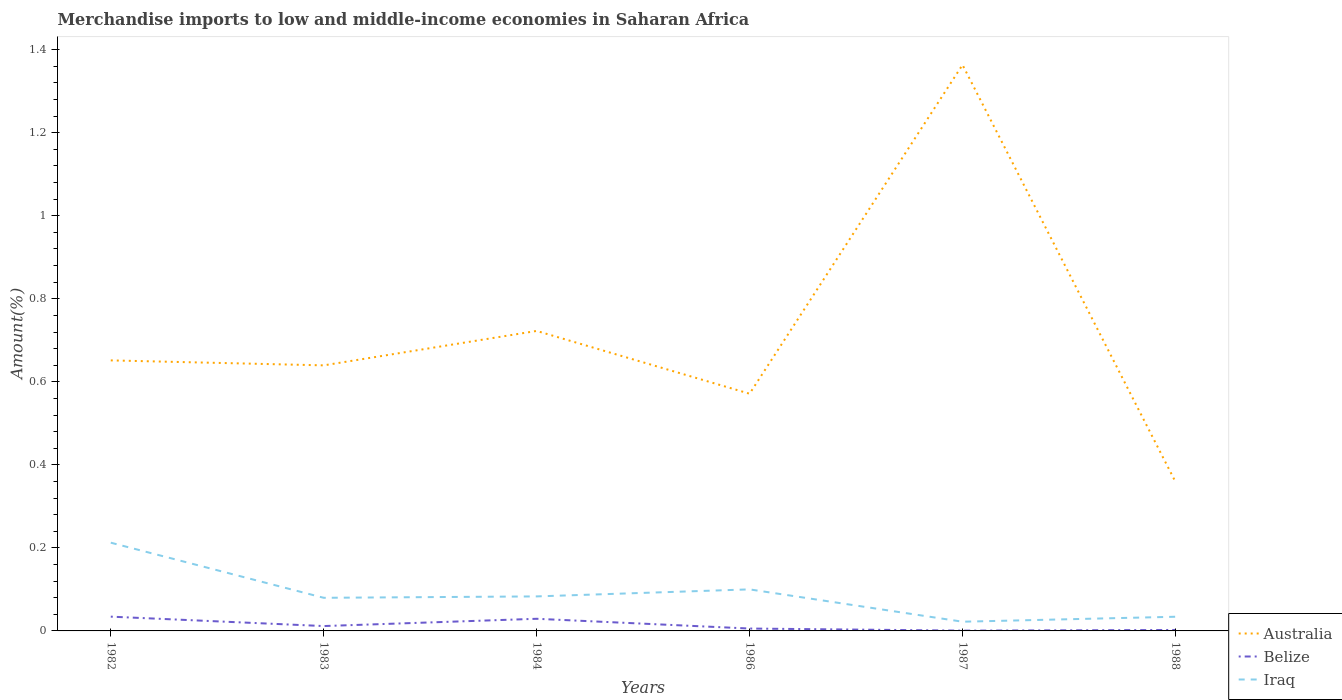Across all years, what is the maximum percentage of amount earned from merchandise imports in Iraq?
Keep it short and to the point. 0.02. What is the total percentage of amount earned from merchandise imports in Australia in the graph?
Your answer should be very brief. 0.28. What is the difference between the highest and the second highest percentage of amount earned from merchandise imports in Australia?
Your response must be concise. 1. Is the percentage of amount earned from merchandise imports in Belize strictly greater than the percentage of amount earned from merchandise imports in Australia over the years?
Your answer should be very brief. Yes. How many lines are there?
Offer a very short reply. 3. Are the values on the major ticks of Y-axis written in scientific E-notation?
Make the answer very short. No. Does the graph contain grids?
Make the answer very short. No. Where does the legend appear in the graph?
Give a very brief answer. Bottom right. How are the legend labels stacked?
Give a very brief answer. Vertical. What is the title of the graph?
Offer a very short reply. Merchandise imports to low and middle-income economies in Saharan Africa. Does "Caribbean small states" appear as one of the legend labels in the graph?
Your response must be concise. No. What is the label or title of the X-axis?
Your response must be concise. Years. What is the label or title of the Y-axis?
Keep it short and to the point. Amount(%). What is the Amount(%) in Australia in 1982?
Your answer should be compact. 0.65. What is the Amount(%) of Belize in 1982?
Your answer should be very brief. 0.03. What is the Amount(%) of Iraq in 1982?
Provide a succinct answer. 0.21. What is the Amount(%) in Australia in 1983?
Offer a terse response. 0.64. What is the Amount(%) of Belize in 1983?
Offer a terse response. 0.01. What is the Amount(%) of Iraq in 1983?
Your answer should be very brief. 0.08. What is the Amount(%) in Australia in 1984?
Offer a very short reply. 0.72. What is the Amount(%) of Belize in 1984?
Your answer should be very brief. 0.03. What is the Amount(%) of Iraq in 1984?
Keep it short and to the point. 0.08. What is the Amount(%) of Australia in 1986?
Provide a short and direct response. 0.57. What is the Amount(%) of Belize in 1986?
Offer a very short reply. 0.01. What is the Amount(%) of Iraq in 1986?
Make the answer very short. 0.1. What is the Amount(%) of Australia in 1987?
Make the answer very short. 1.36. What is the Amount(%) of Belize in 1987?
Offer a very short reply. 0. What is the Amount(%) in Iraq in 1987?
Provide a short and direct response. 0.02. What is the Amount(%) of Australia in 1988?
Offer a terse response. 0.36. What is the Amount(%) of Belize in 1988?
Offer a very short reply. 0. What is the Amount(%) of Iraq in 1988?
Your answer should be compact. 0.03. Across all years, what is the maximum Amount(%) of Australia?
Provide a short and direct response. 1.36. Across all years, what is the maximum Amount(%) of Belize?
Ensure brevity in your answer.  0.03. Across all years, what is the maximum Amount(%) of Iraq?
Provide a succinct answer. 0.21. Across all years, what is the minimum Amount(%) of Australia?
Provide a succinct answer. 0.36. Across all years, what is the minimum Amount(%) in Belize?
Your answer should be compact. 0. Across all years, what is the minimum Amount(%) in Iraq?
Make the answer very short. 0.02. What is the total Amount(%) in Australia in the graph?
Your answer should be compact. 4.31. What is the total Amount(%) of Belize in the graph?
Provide a short and direct response. 0.08. What is the total Amount(%) in Iraq in the graph?
Your answer should be compact. 0.53. What is the difference between the Amount(%) in Australia in 1982 and that in 1983?
Make the answer very short. 0.01. What is the difference between the Amount(%) of Belize in 1982 and that in 1983?
Your response must be concise. 0.02. What is the difference between the Amount(%) of Iraq in 1982 and that in 1983?
Ensure brevity in your answer.  0.13. What is the difference between the Amount(%) of Australia in 1982 and that in 1984?
Keep it short and to the point. -0.07. What is the difference between the Amount(%) in Belize in 1982 and that in 1984?
Your answer should be very brief. 0.01. What is the difference between the Amount(%) of Iraq in 1982 and that in 1984?
Provide a short and direct response. 0.13. What is the difference between the Amount(%) in Australia in 1982 and that in 1986?
Offer a very short reply. 0.08. What is the difference between the Amount(%) in Belize in 1982 and that in 1986?
Offer a terse response. 0.03. What is the difference between the Amount(%) of Iraq in 1982 and that in 1986?
Your response must be concise. 0.11. What is the difference between the Amount(%) in Australia in 1982 and that in 1987?
Your answer should be very brief. -0.71. What is the difference between the Amount(%) in Belize in 1982 and that in 1987?
Your response must be concise. 0.03. What is the difference between the Amount(%) of Iraq in 1982 and that in 1987?
Make the answer very short. 0.19. What is the difference between the Amount(%) of Australia in 1982 and that in 1988?
Provide a succinct answer. 0.29. What is the difference between the Amount(%) of Belize in 1982 and that in 1988?
Provide a succinct answer. 0.03. What is the difference between the Amount(%) in Iraq in 1982 and that in 1988?
Give a very brief answer. 0.18. What is the difference between the Amount(%) in Australia in 1983 and that in 1984?
Give a very brief answer. -0.08. What is the difference between the Amount(%) of Belize in 1983 and that in 1984?
Provide a short and direct response. -0.02. What is the difference between the Amount(%) in Iraq in 1983 and that in 1984?
Your answer should be compact. -0. What is the difference between the Amount(%) of Australia in 1983 and that in 1986?
Ensure brevity in your answer.  0.07. What is the difference between the Amount(%) in Belize in 1983 and that in 1986?
Your response must be concise. 0.01. What is the difference between the Amount(%) of Iraq in 1983 and that in 1986?
Ensure brevity in your answer.  -0.02. What is the difference between the Amount(%) in Australia in 1983 and that in 1987?
Your response must be concise. -0.72. What is the difference between the Amount(%) of Belize in 1983 and that in 1987?
Ensure brevity in your answer.  0.01. What is the difference between the Amount(%) of Iraq in 1983 and that in 1987?
Ensure brevity in your answer.  0.06. What is the difference between the Amount(%) in Australia in 1983 and that in 1988?
Make the answer very short. 0.28. What is the difference between the Amount(%) of Belize in 1983 and that in 1988?
Offer a very short reply. 0.01. What is the difference between the Amount(%) of Iraq in 1983 and that in 1988?
Ensure brevity in your answer.  0.05. What is the difference between the Amount(%) of Australia in 1984 and that in 1986?
Offer a very short reply. 0.15. What is the difference between the Amount(%) in Belize in 1984 and that in 1986?
Give a very brief answer. 0.02. What is the difference between the Amount(%) of Iraq in 1984 and that in 1986?
Provide a short and direct response. -0.02. What is the difference between the Amount(%) in Australia in 1984 and that in 1987?
Give a very brief answer. -0.64. What is the difference between the Amount(%) in Belize in 1984 and that in 1987?
Keep it short and to the point. 0.03. What is the difference between the Amount(%) of Iraq in 1984 and that in 1987?
Give a very brief answer. 0.06. What is the difference between the Amount(%) of Australia in 1984 and that in 1988?
Ensure brevity in your answer.  0.36. What is the difference between the Amount(%) in Belize in 1984 and that in 1988?
Keep it short and to the point. 0.03. What is the difference between the Amount(%) in Iraq in 1984 and that in 1988?
Give a very brief answer. 0.05. What is the difference between the Amount(%) of Australia in 1986 and that in 1987?
Make the answer very short. -0.79. What is the difference between the Amount(%) of Belize in 1986 and that in 1987?
Your answer should be compact. 0.01. What is the difference between the Amount(%) in Iraq in 1986 and that in 1987?
Your answer should be very brief. 0.08. What is the difference between the Amount(%) of Australia in 1986 and that in 1988?
Provide a succinct answer. 0.21. What is the difference between the Amount(%) of Belize in 1986 and that in 1988?
Ensure brevity in your answer.  0. What is the difference between the Amount(%) in Iraq in 1986 and that in 1988?
Provide a short and direct response. 0.07. What is the difference between the Amount(%) of Belize in 1987 and that in 1988?
Offer a very short reply. -0. What is the difference between the Amount(%) of Iraq in 1987 and that in 1988?
Your response must be concise. -0.01. What is the difference between the Amount(%) in Australia in 1982 and the Amount(%) in Belize in 1983?
Give a very brief answer. 0.64. What is the difference between the Amount(%) in Australia in 1982 and the Amount(%) in Iraq in 1983?
Give a very brief answer. 0.57. What is the difference between the Amount(%) in Belize in 1982 and the Amount(%) in Iraq in 1983?
Your response must be concise. -0.05. What is the difference between the Amount(%) in Australia in 1982 and the Amount(%) in Belize in 1984?
Offer a very short reply. 0.62. What is the difference between the Amount(%) in Australia in 1982 and the Amount(%) in Iraq in 1984?
Your answer should be compact. 0.57. What is the difference between the Amount(%) in Belize in 1982 and the Amount(%) in Iraq in 1984?
Offer a terse response. -0.05. What is the difference between the Amount(%) in Australia in 1982 and the Amount(%) in Belize in 1986?
Provide a succinct answer. 0.65. What is the difference between the Amount(%) of Australia in 1982 and the Amount(%) of Iraq in 1986?
Give a very brief answer. 0.55. What is the difference between the Amount(%) in Belize in 1982 and the Amount(%) in Iraq in 1986?
Provide a succinct answer. -0.07. What is the difference between the Amount(%) of Australia in 1982 and the Amount(%) of Belize in 1987?
Give a very brief answer. 0.65. What is the difference between the Amount(%) in Australia in 1982 and the Amount(%) in Iraq in 1987?
Your response must be concise. 0.63. What is the difference between the Amount(%) of Belize in 1982 and the Amount(%) of Iraq in 1987?
Keep it short and to the point. 0.01. What is the difference between the Amount(%) in Australia in 1982 and the Amount(%) in Belize in 1988?
Give a very brief answer. 0.65. What is the difference between the Amount(%) of Australia in 1982 and the Amount(%) of Iraq in 1988?
Your answer should be very brief. 0.62. What is the difference between the Amount(%) in Belize in 1982 and the Amount(%) in Iraq in 1988?
Your response must be concise. 0. What is the difference between the Amount(%) of Australia in 1983 and the Amount(%) of Belize in 1984?
Your response must be concise. 0.61. What is the difference between the Amount(%) of Australia in 1983 and the Amount(%) of Iraq in 1984?
Give a very brief answer. 0.56. What is the difference between the Amount(%) of Belize in 1983 and the Amount(%) of Iraq in 1984?
Offer a very short reply. -0.07. What is the difference between the Amount(%) in Australia in 1983 and the Amount(%) in Belize in 1986?
Offer a very short reply. 0.63. What is the difference between the Amount(%) of Australia in 1983 and the Amount(%) of Iraq in 1986?
Your answer should be very brief. 0.54. What is the difference between the Amount(%) in Belize in 1983 and the Amount(%) in Iraq in 1986?
Provide a succinct answer. -0.09. What is the difference between the Amount(%) in Australia in 1983 and the Amount(%) in Belize in 1987?
Keep it short and to the point. 0.64. What is the difference between the Amount(%) of Australia in 1983 and the Amount(%) of Iraq in 1987?
Your response must be concise. 0.62. What is the difference between the Amount(%) of Belize in 1983 and the Amount(%) of Iraq in 1987?
Provide a succinct answer. -0.01. What is the difference between the Amount(%) of Australia in 1983 and the Amount(%) of Belize in 1988?
Keep it short and to the point. 0.64. What is the difference between the Amount(%) of Australia in 1983 and the Amount(%) of Iraq in 1988?
Offer a terse response. 0.61. What is the difference between the Amount(%) in Belize in 1983 and the Amount(%) in Iraq in 1988?
Your answer should be compact. -0.02. What is the difference between the Amount(%) of Australia in 1984 and the Amount(%) of Belize in 1986?
Make the answer very short. 0.72. What is the difference between the Amount(%) in Australia in 1984 and the Amount(%) in Iraq in 1986?
Give a very brief answer. 0.62. What is the difference between the Amount(%) in Belize in 1984 and the Amount(%) in Iraq in 1986?
Your answer should be compact. -0.07. What is the difference between the Amount(%) in Australia in 1984 and the Amount(%) in Belize in 1987?
Make the answer very short. 0.72. What is the difference between the Amount(%) in Australia in 1984 and the Amount(%) in Iraq in 1987?
Your answer should be compact. 0.7. What is the difference between the Amount(%) of Belize in 1984 and the Amount(%) of Iraq in 1987?
Your response must be concise. 0.01. What is the difference between the Amount(%) in Australia in 1984 and the Amount(%) in Belize in 1988?
Offer a very short reply. 0.72. What is the difference between the Amount(%) of Australia in 1984 and the Amount(%) of Iraq in 1988?
Your answer should be very brief. 0.69. What is the difference between the Amount(%) in Belize in 1984 and the Amount(%) in Iraq in 1988?
Make the answer very short. -0. What is the difference between the Amount(%) of Australia in 1986 and the Amount(%) of Belize in 1987?
Ensure brevity in your answer.  0.57. What is the difference between the Amount(%) of Australia in 1986 and the Amount(%) of Iraq in 1987?
Provide a succinct answer. 0.55. What is the difference between the Amount(%) in Belize in 1986 and the Amount(%) in Iraq in 1987?
Your answer should be very brief. -0.02. What is the difference between the Amount(%) in Australia in 1986 and the Amount(%) in Belize in 1988?
Your answer should be compact. 0.57. What is the difference between the Amount(%) in Australia in 1986 and the Amount(%) in Iraq in 1988?
Make the answer very short. 0.54. What is the difference between the Amount(%) of Belize in 1986 and the Amount(%) of Iraq in 1988?
Your response must be concise. -0.03. What is the difference between the Amount(%) in Australia in 1987 and the Amount(%) in Belize in 1988?
Provide a succinct answer. 1.36. What is the difference between the Amount(%) of Australia in 1987 and the Amount(%) of Iraq in 1988?
Make the answer very short. 1.33. What is the difference between the Amount(%) of Belize in 1987 and the Amount(%) of Iraq in 1988?
Offer a very short reply. -0.03. What is the average Amount(%) of Australia per year?
Your answer should be compact. 0.72. What is the average Amount(%) in Belize per year?
Your answer should be very brief. 0.01. What is the average Amount(%) in Iraq per year?
Your answer should be compact. 0.09. In the year 1982, what is the difference between the Amount(%) of Australia and Amount(%) of Belize?
Your answer should be very brief. 0.62. In the year 1982, what is the difference between the Amount(%) in Australia and Amount(%) in Iraq?
Your answer should be compact. 0.44. In the year 1982, what is the difference between the Amount(%) of Belize and Amount(%) of Iraq?
Offer a terse response. -0.18. In the year 1983, what is the difference between the Amount(%) in Australia and Amount(%) in Belize?
Provide a succinct answer. 0.63. In the year 1983, what is the difference between the Amount(%) in Australia and Amount(%) in Iraq?
Ensure brevity in your answer.  0.56. In the year 1983, what is the difference between the Amount(%) of Belize and Amount(%) of Iraq?
Your response must be concise. -0.07. In the year 1984, what is the difference between the Amount(%) in Australia and Amount(%) in Belize?
Ensure brevity in your answer.  0.69. In the year 1984, what is the difference between the Amount(%) in Australia and Amount(%) in Iraq?
Your answer should be very brief. 0.64. In the year 1984, what is the difference between the Amount(%) in Belize and Amount(%) in Iraq?
Keep it short and to the point. -0.05. In the year 1986, what is the difference between the Amount(%) of Australia and Amount(%) of Belize?
Give a very brief answer. 0.57. In the year 1986, what is the difference between the Amount(%) in Australia and Amount(%) in Iraq?
Provide a succinct answer. 0.47. In the year 1986, what is the difference between the Amount(%) in Belize and Amount(%) in Iraq?
Provide a short and direct response. -0.09. In the year 1987, what is the difference between the Amount(%) of Australia and Amount(%) of Belize?
Your response must be concise. 1.36. In the year 1987, what is the difference between the Amount(%) in Australia and Amount(%) in Iraq?
Your response must be concise. 1.34. In the year 1987, what is the difference between the Amount(%) in Belize and Amount(%) in Iraq?
Keep it short and to the point. -0.02. In the year 1988, what is the difference between the Amount(%) of Australia and Amount(%) of Belize?
Keep it short and to the point. 0.36. In the year 1988, what is the difference between the Amount(%) in Australia and Amount(%) in Iraq?
Your answer should be compact. 0.33. In the year 1988, what is the difference between the Amount(%) of Belize and Amount(%) of Iraq?
Provide a succinct answer. -0.03. What is the ratio of the Amount(%) of Australia in 1982 to that in 1983?
Provide a short and direct response. 1.02. What is the ratio of the Amount(%) in Belize in 1982 to that in 1983?
Your answer should be very brief. 2.93. What is the ratio of the Amount(%) of Iraq in 1982 to that in 1983?
Your response must be concise. 2.66. What is the ratio of the Amount(%) of Australia in 1982 to that in 1984?
Keep it short and to the point. 0.9. What is the ratio of the Amount(%) in Belize in 1982 to that in 1984?
Keep it short and to the point. 1.18. What is the ratio of the Amount(%) of Iraq in 1982 to that in 1984?
Ensure brevity in your answer.  2.56. What is the ratio of the Amount(%) of Australia in 1982 to that in 1986?
Give a very brief answer. 1.14. What is the ratio of the Amount(%) in Belize in 1982 to that in 1986?
Give a very brief answer. 5.99. What is the ratio of the Amount(%) in Iraq in 1982 to that in 1986?
Ensure brevity in your answer.  2.12. What is the ratio of the Amount(%) of Australia in 1982 to that in 1987?
Make the answer very short. 0.48. What is the ratio of the Amount(%) in Belize in 1982 to that in 1987?
Your response must be concise. 48.93. What is the ratio of the Amount(%) in Iraq in 1982 to that in 1987?
Make the answer very short. 9.58. What is the ratio of the Amount(%) in Australia in 1982 to that in 1988?
Ensure brevity in your answer.  1.81. What is the ratio of the Amount(%) in Belize in 1982 to that in 1988?
Make the answer very short. 14.99. What is the ratio of the Amount(%) in Iraq in 1982 to that in 1988?
Provide a succinct answer. 6.22. What is the ratio of the Amount(%) of Australia in 1983 to that in 1984?
Keep it short and to the point. 0.89. What is the ratio of the Amount(%) of Belize in 1983 to that in 1984?
Make the answer very short. 0.4. What is the ratio of the Amount(%) of Iraq in 1983 to that in 1984?
Provide a short and direct response. 0.96. What is the ratio of the Amount(%) in Australia in 1983 to that in 1986?
Make the answer very short. 1.12. What is the ratio of the Amount(%) in Belize in 1983 to that in 1986?
Provide a short and direct response. 2.04. What is the ratio of the Amount(%) in Iraq in 1983 to that in 1986?
Offer a terse response. 0.8. What is the ratio of the Amount(%) of Australia in 1983 to that in 1987?
Keep it short and to the point. 0.47. What is the ratio of the Amount(%) of Belize in 1983 to that in 1987?
Provide a short and direct response. 16.69. What is the ratio of the Amount(%) of Iraq in 1983 to that in 1987?
Ensure brevity in your answer.  3.6. What is the ratio of the Amount(%) in Australia in 1983 to that in 1988?
Provide a succinct answer. 1.78. What is the ratio of the Amount(%) in Belize in 1983 to that in 1988?
Your answer should be very brief. 5.11. What is the ratio of the Amount(%) of Iraq in 1983 to that in 1988?
Keep it short and to the point. 2.34. What is the ratio of the Amount(%) of Australia in 1984 to that in 1986?
Ensure brevity in your answer.  1.26. What is the ratio of the Amount(%) in Belize in 1984 to that in 1986?
Offer a terse response. 5.09. What is the ratio of the Amount(%) in Iraq in 1984 to that in 1986?
Provide a short and direct response. 0.83. What is the ratio of the Amount(%) in Australia in 1984 to that in 1987?
Keep it short and to the point. 0.53. What is the ratio of the Amount(%) in Belize in 1984 to that in 1987?
Provide a short and direct response. 41.62. What is the ratio of the Amount(%) of Iraq in 1984 to that in 1987?
Your answer should be very brief. 3.75. What is the ratio of the Amount(%) of Australia in 1984 to that in 1988?
Your response must be concise. 2.01. What is the ratio of the Amount(%) of Belize in 1984 to that in 1988?
Your answer should be very brief. 12.75. What is the ratio of the Amount(%) of Iraq in 1984 to that in 1988?
Offer a terse response. 2.43. What is the ratio of the Amount(%) in Australia in 1986 to that in 1987?
Your answer should be very brief. 0.42. What is the ratio of the Amount(%) of Belize in 1986 to that in 1987?
Make the answer very short. 8.17. What is the ratio of the Amount(%) in Iraq in 1986 to that in 1987?
Your response must be concise. 4.51. What is the ratio of the Amount(%) of Australia in 1986 to that in 1988?
Keep it short and to the point. 1.59. What is the ratio of the Amount(%) in Belize in 1986 to that in 1988?
Keep it short and to the point. 2.5. What is the ratio of the Amount(%) of Iraq in 1986 to that in 1988?
Make the answer very short. 2.93. What is the ratio of the Amount(%) of Australia in 1987 to that in 1988?
Ensure brevity in your answer.  3.8. What is the ratio of the Amount(%) of Belize in 1987 to that in 1988?
Make the answer very short. 0.31. What is the ratio of the Amount(%) in Iraq in 1987 to that in 1988?
Ensure brevity in your answer.  0.65. What is the difference between the highest and the second highest Amount(%) in Australia?
Your answer should be compact. 0.64. What is the difference between the highest and the second highest Amount(%) in Belize?
Make the answer very short. 0.01. What is the difference between the highest and the second highest Amount(%) in Iraq?
Give a very brief answer. 0.11. What is the difference between the highest and the lowest Amount(%) of Australia?
Provide a succinct answer. 1. What is the difference between the highest and the lowest Amount(%) of Belize?
Offer a terse response. 0.03. What is the difference between the highest and the lowest Amount(%) of Iraq?
Offer a terse response. 0.19. 